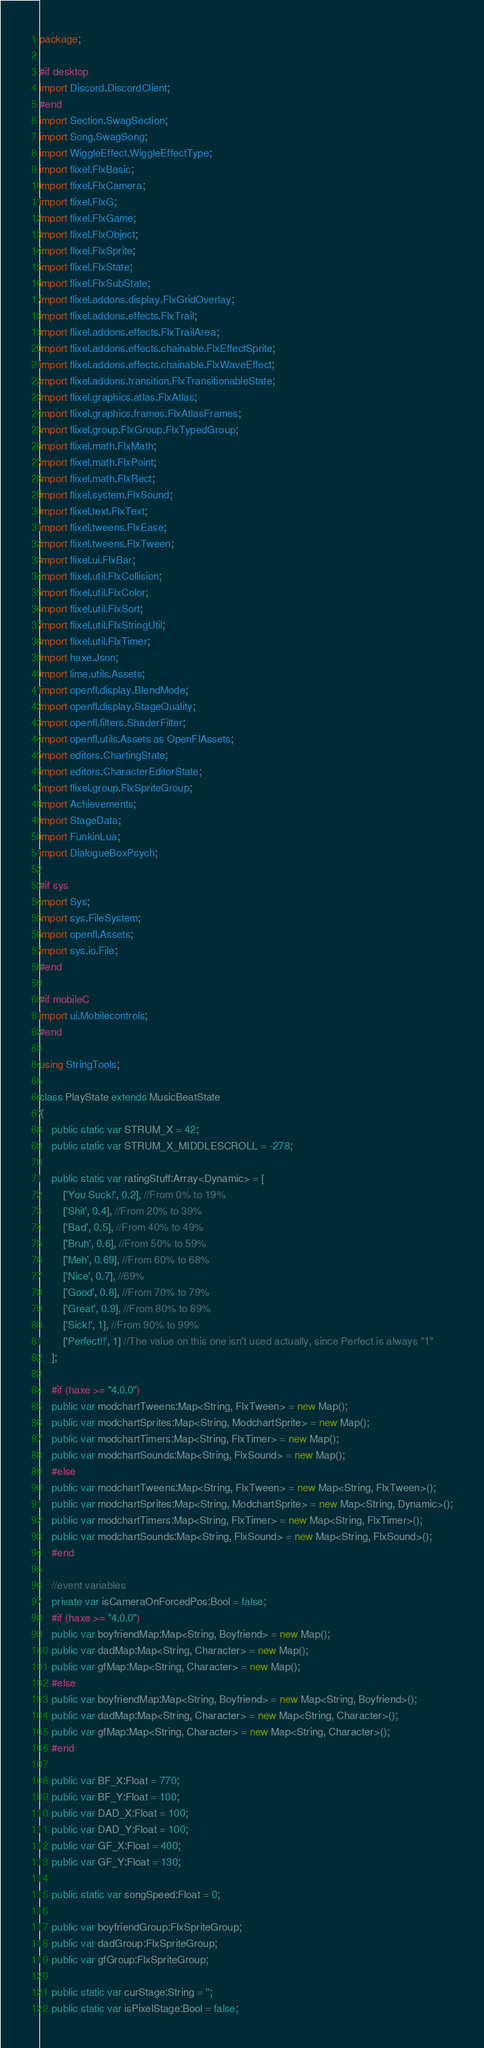<code> <loc_0><loc_0><loc_500><loc_500><_Haxe_>package;

#if desktop
import Discord.DiscordClient;
#end
import Section.SwagSection;
import Song.SwagSong;
import WiggleEffect.WiggleEffectType;
import flixel.FlxBasic;
import flixel.FlxCamera;
import flixel.FlxG;
import flixel.FlxGame;
import flixel.FlxObject;
import flixel.FlxSprite;
import flixel.FlxState;
import flixel.FlxSubState;
import flixel.addons.display.FlxGridOverlay;
import flixel.addons.effects.FlxTrail;
import flixel.addons.effects.FlxTrailArea;
import flixel.addons.effects.chainable.FlxEffectSprite;
import flixel.addons.effects.chainable.FlxWaveEffect;
import flixel.addons.transition.FlxTransitionableState;
import flixel.graphics.atlas.FlxAtlas;
import flixel.graphics.frames.FlxAtlasFrames;
import flixel.group.FlxGroup.FlxTypedGroup;
import flixel.math.FlxMath;
import flixel.math.FlxPoint;
import flixel.math.FlxRect;
import flixel.system.FlxSound;
import flixel.text.FlxText;
import flixel.tweens.FlxEase;
import flixel.tweens.FlxTween;
import flixel.ui.FlxBar;
import flixel.util.FlxCollision;
import flixel.util.FlxColor;
import flixel.util.FlxSort;
import flixel.util.FlxStringUtil;
import flixel.util.FlxTimer;
import haxe.Json;
import lime.utils.Assets;
import openfl.display.BlendMode;
import openfl.display.StageQuality;
import openfl.filters.ShaderFilter;
import openfl.utils.Assets as OpenFlAssets;
import editors.ChartingState;
import editors.CharacterEditorState;
import flixel.group.FlxSpriteGroup;
import Achievements;
import StageData;
import FunkinLua;
import DialogueBoxPsych;

#if sys
import Sys;
import sys.FileSystem;
import openfl.Assets;
import sys.io.File;
#end

#if mobileC
import ui.Mobilecontrols;
#end

using StringTools;

class PlayState extends MusicBeatState
{
	public static var STRUM_X = 42;
	public static var STRUM_X_MIDDLESCROLL = -278;

	public static var ratingStuff:Array<Dynamic> = [
		['You Suck!', 0.2], //From 0% to 19%
		['Shit', 0.4], //From 20% to 39%
		['Bad', 0.5], //From 40% to 49%
		['Bruh', 0.6], //From 50% to 59%
		['Meh', 0.69], //From 60% to 68%
		['Nice', 0.7], //69%
		['Good', 0.8], //From 70% to 79%
		['Great', 0.9], //From 80% to 89%
		['Sick!', 1], //From 90% to 99%
		['Perfect!!', 1] //The value on this one isn't used actually, since Perfect is always "1"
	];
	
	#if (haxe >= "4.0.0")
	public var modchartTweens:Map<String, FlxTween> = new Map();
	public var modchartSprites:Map<String, ModchartSprite> = new Map();
	public var modchartTimers:Map<String, FlxTimer> = new Map();
	public var modchartSounds:Map<String, FlxSound> = new Map();
	#else
	public var modchartTweens:Map<String, FlxTween> = new Map<String, FlxTween>();
	public var modchartSprites:Map<String, ModchartSprite> = new Map<String, Dynamic>();
	public var modchartTimers:Map<String, FlxTimer> = new Map<String, FlxTimer>();
	public var modchartSounds:Map<String, FlxSound> = new Map<String, FlxSound>();
	#end

	//event variables
	private var isCameraOnForcedPos:Bool = false;
	#if (haxe >= "4.0.0")
	public var boyfriendMap:Map<String, Boyfriend> = new Map();
	public var dadMap:Map<String, Character> = new Map();
	public var gfMap:Map<String, Character> = new Map();
	#else
	public var boyfriendMap:Map<String, Boyfriend> = new Map<String, Boyfriend>();
	public var dadMap:Map<String, Character> = new Map<String, Character>();
	public var gfMap:Map<String, Character> = new Map<String, Character>();
	#end

	public var BF_X:Float = 770;
	public var BF_Y:Float = 100;
	public var DAD_X:Float = 100;
	public var DAD_Y:Float = 100;
	public var GF_X:Float = 400;
	public var GF_Y:Float = 130;
	
	public static var songSpeed:Float = 0;
	
	public var boyfriendGroup:FlxSpriteGroup;
	public var dadGroup:FlxSpriteGroup;
	public var gfGroup:FlxSpriteGroup;

	public static var curStage:String = '';
	public static var isPixelStage:Bool = false;</code> 